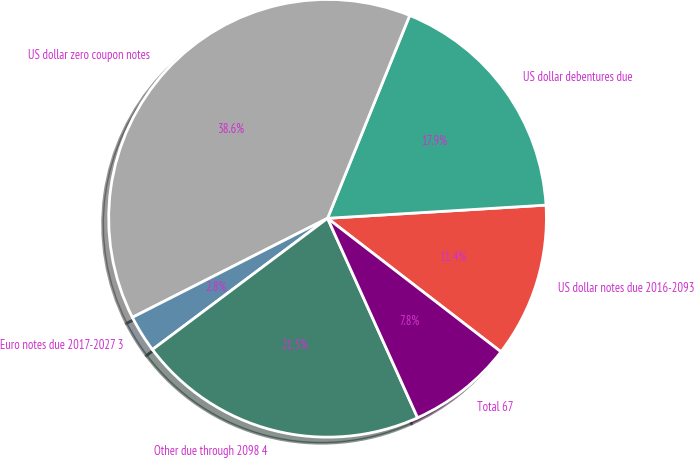<chart> <loc_0><loc_0><loc_500><loc_500><pie_chart><fcel>US dollar notes due 2016-2093<fcel>US dollar debentures due<fcel>US dollar zero coupon notes<fcel>Euro notes due 2017-2027 3<fcel>Other due through 2098 4<fcel>Total 67<nl><fcel>11.4%<fcel>17.92%<fcel>38.6%<fcel>2.76%<fcel>21.51%<fcel>7.81%<nl></chart> 